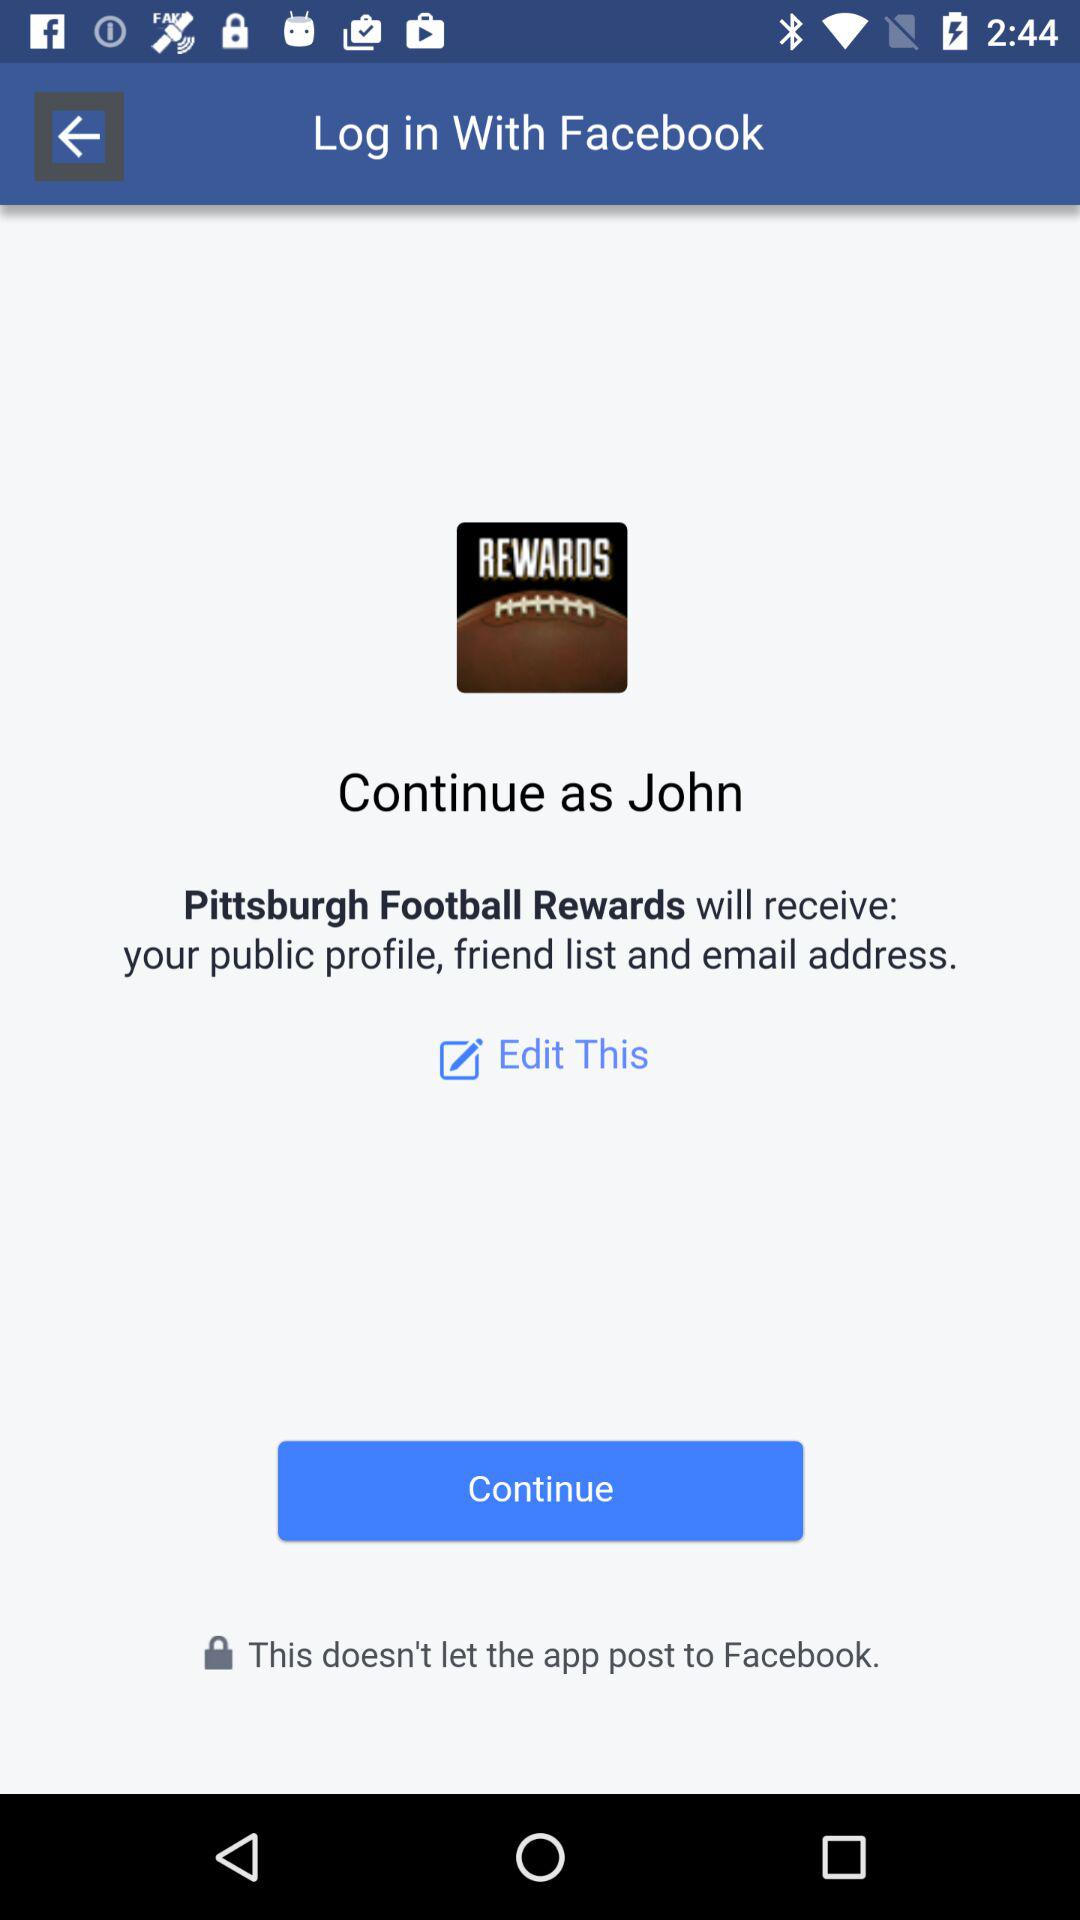What application is asking for permission? The application that is asking for permission is "Pittsburgh Football Rewards". 